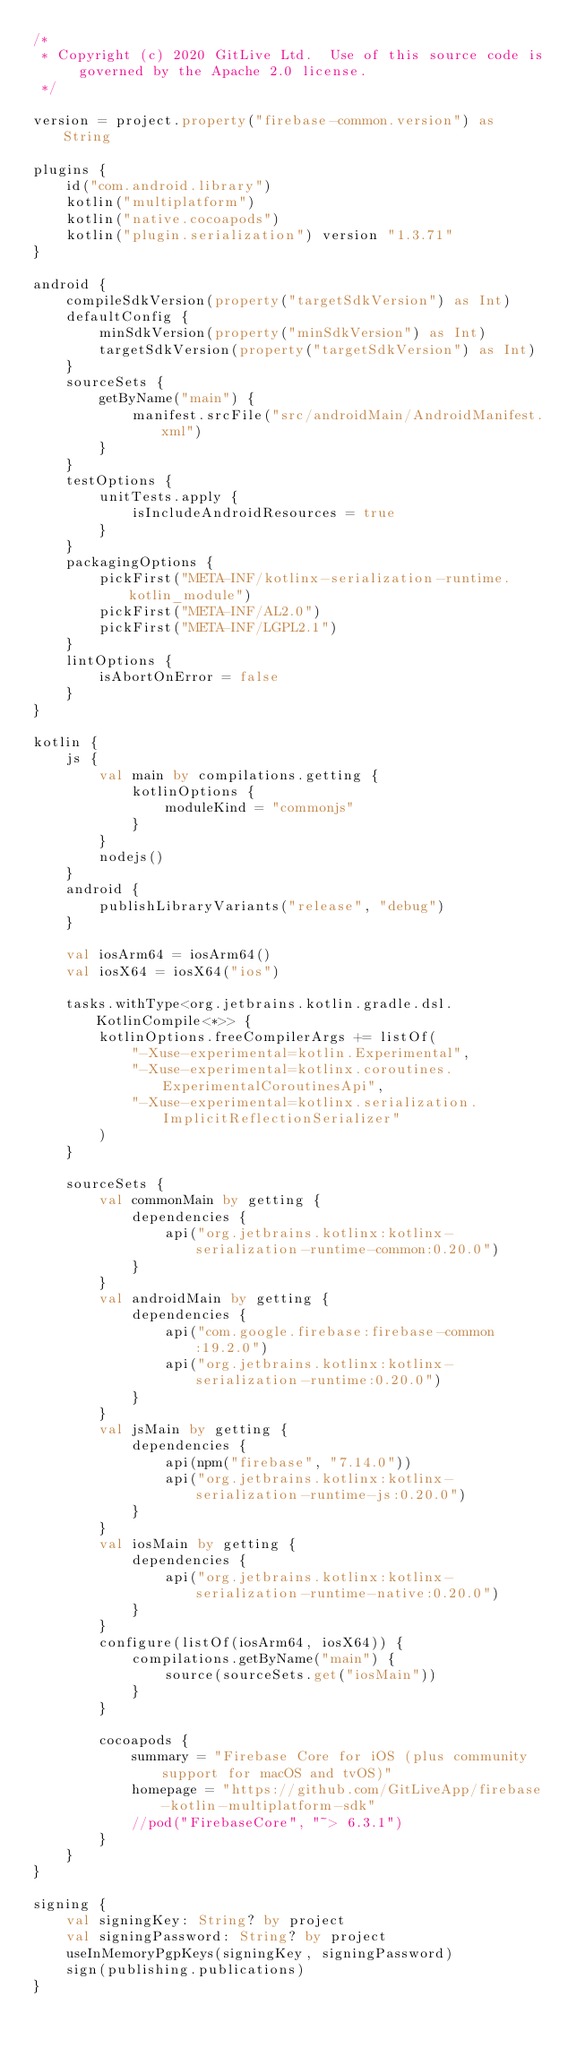Convert code to text. <code><loc_0><loc_0><loc_500><loc_500><_Kotlin_>/*
 * Copyright (c) 2020 GitLive Ltd.  Use of this source code is governed by the Apache 2.0 license.
 */

version = project.property("firebase-common.version") as String

plugins {
    id("com.android.library")
    kotlin("multiplatform")
    kotlin("native.cocoapods")
    kotlin("plugin.serialization") version "1.3.71"
}

android {
    compileSdkVersion(property("targetSdkVersion") as Int)
    defaultConfig {
        minSdkVersion(property("minSdkVersion") as Int)
        targetSdkVersion(property("targetSdkVersion") as Int)
    }
    sourceSets {
        getByName("main") {
            manifest.srcFile("src/androidMain/AndroidManifest.xml")
        }
    }
    testOptions {
        unitTests.apply {
            isIncludeAndroidResources = true
        }
    }
    packagingOptions {
        pickFirst("META-INF/kotlinx-serialization-runtime.kotlin_module")
        pickFirst("META-INF/AL2.0")
        pickFirst("META-INF/LGPL2.1")
    }
    lintOptions {
        isAbortOnError = false
    }
}

kotlin {
    js {
        val main by compilations.getting {
            kotlinOptions {
                moduleKind = "commonjs"
            }
        }
        nodejs()
    }
    android {
        publishLibraryVariants("release", "debug")
    }

    val iosArm64 = iosArm64()
    val iosX64 = iosX64("ios")

    tasks.withType<org.jetbrains.kotlin.gradle.dsl.KotlinCompile<*>> {
        kotlinOptions.freeCompilerArgs += listOf(
            "-Xuse-experimental=kotlin.Experimental",
            "-Xuse-experimental=kotlinx.coroutines.ExperimentalCoroutinesApi",
            "-Xuse-experimental=kotlinx.serialization.ImplicitReflectionSerializer"
        )
    }

    sourceSets {
        val commonMain by getting {
            dependencies {
                api("org.jetbrains.kotlinx:kotlinx-serialization-runtime-common:0.20.0")
            }
        }
        val androidMain by getting {
            dependencies {
                api("com.google.firebase:firebase-common:19.2.0")
                api("org.jetbrains.kotlinx:kotlinx-serialization-runtime:0.20.0")
            }
        }
        val jsMain by getting {
            dependencies {
                api(npm("firebase", "7.14.0"))
                api("org.jetbrains.kotlinx:kotlinx-serialization-runtime-js:0.20.0")
            }
        }
        val iosMain by getting {
            dependencies {
                api("org.jetbrains.kotlinx:kotlinx-serialization-runtime-native:0.20.0")
            }
        }
        configure(listOf(iosArm64, iosX64)) {
            compilations.getByName("main") {
                source(sourceSets.get("iosMain"))
            }
        }

        cocoapods {
            summary = "Firebase Core for iOS (plus community support for macOS and tvOS)"
            homepage = "https://github.com/GitLiveApp/firebase-kotlin-multiplatform-sdk"
            //pod("FirebaseCore", "~> 6.3.1")
        }
    }
}

signing {
    val signingKey: String? by project
    val signingPassword: String? by project
    useInMemoryPgpKeys(signingKey, signingPassword)
    sign(publishing.publications)
}

</code> 